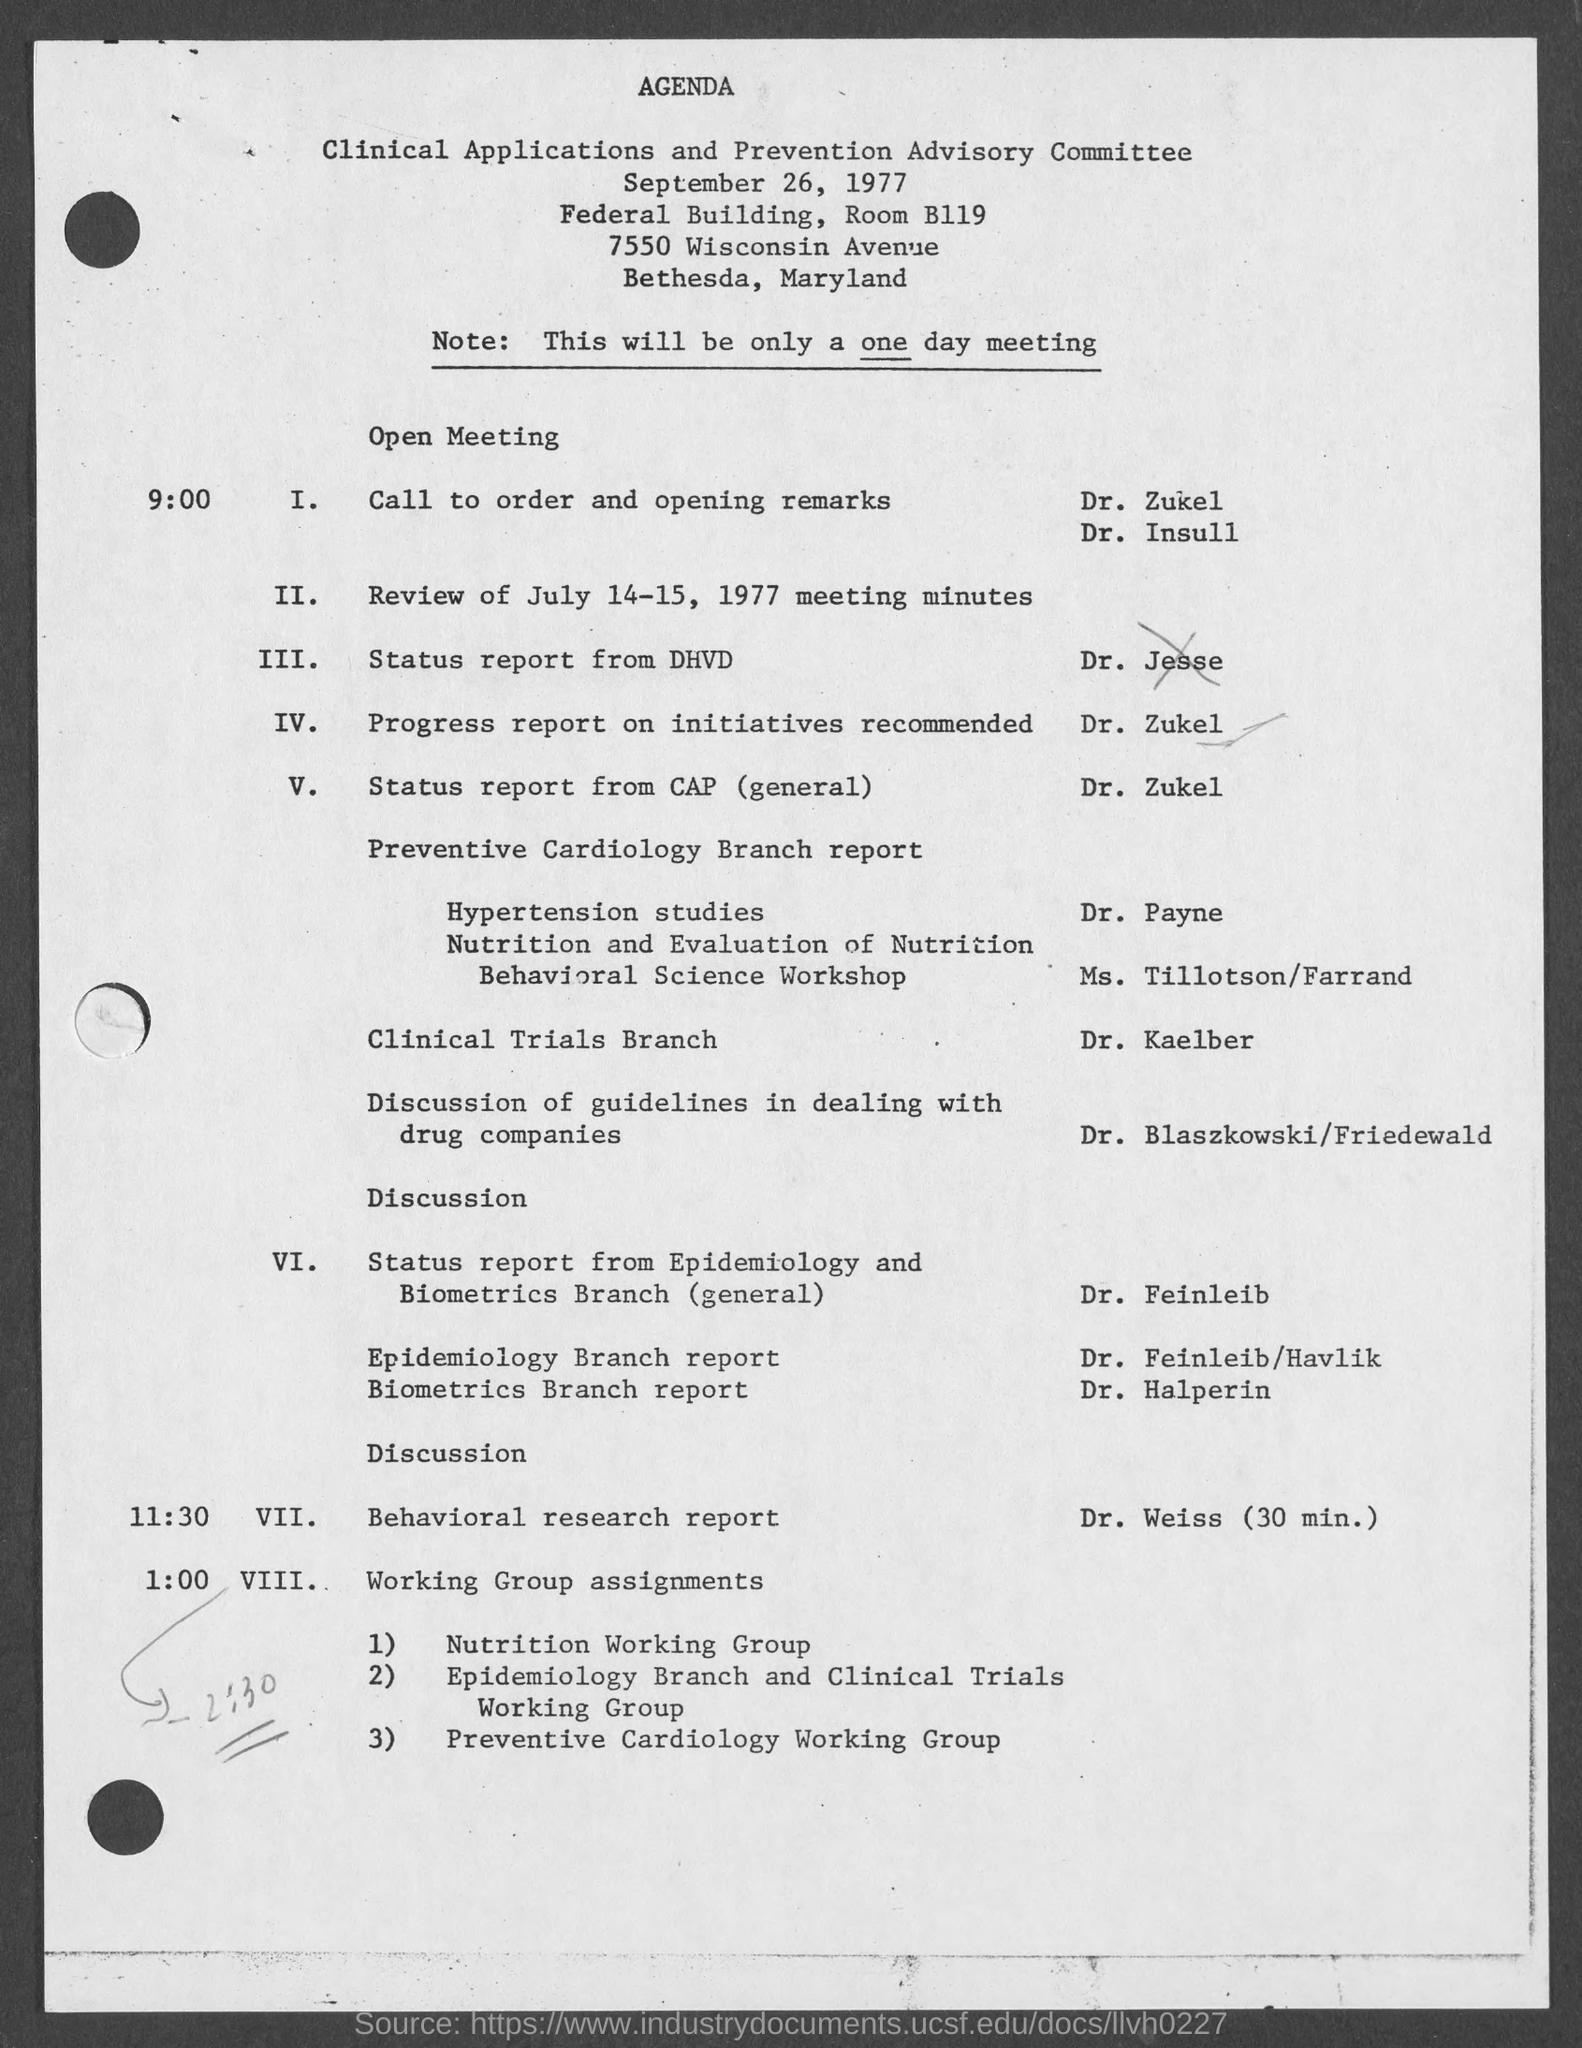When will the meeting be held?
Your answer should be compact. September 26, 1977. Where will the meeting be held?
Your answer should be very brief. Federal Building, Room B119. 